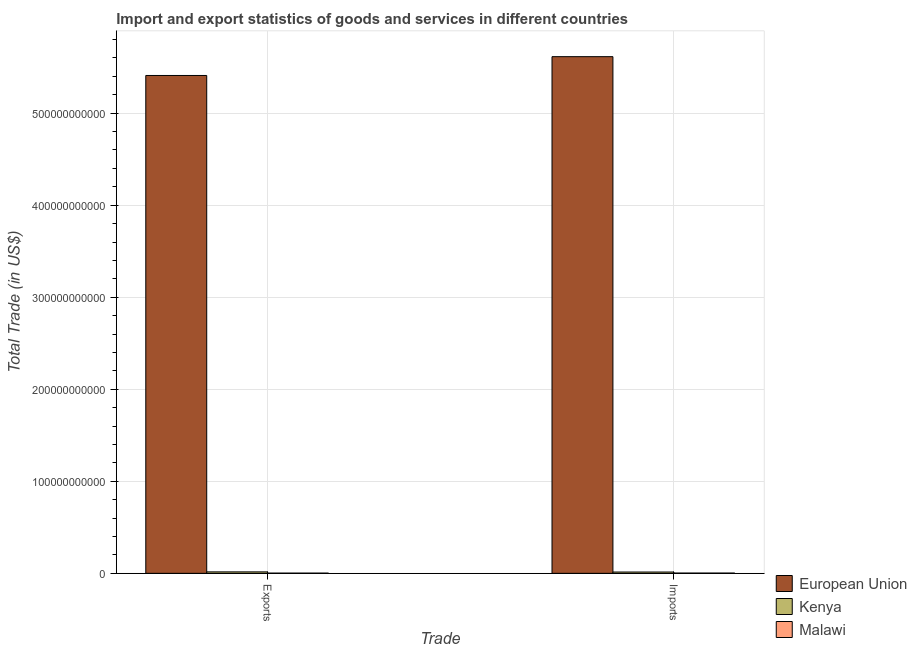How many different coloured bars are there?
Provide a succinct answer. 3. How many groups of bars are there?
Your response must be concise. 2. How many bars are there on the 1st tick from the right?
Keep it short and to the point. 3. What is the label of the 1st group of bars from the left?
Ensure brevity in your answer.  Exports. What is the imports of goods and services in Kenya?
Your response must be concise. 1.42e+09. Across all countries, what is the maximum export of goods and services?
Ensure brevity in your answer.  5.41e+11. Across all countries, what is the minimum imports of goods and services?
Offer a very short reply. 2.79e+08. In which country was the export of goods and services maximum?
Your answer should be compact. European Union. In which country was the export of goods and services minimum?
Offer a very short reply. Malawi. What is the total export of goods and services in the graph?
Ensure brevity in your answer.  5.43e+11. What is the difference between the export of goods and services in Kenya and that in European Union?
Provide a succinct answer. -5.39e+11. What is the difference between the imports of goods and services in European Union and the export of goods and services in Kenya?
Offer a very short reply. 5.60e+11. What is the average export of goods and services per country?
Your answer should be very brief. 1.81e+11. What is the difference between the imports of goods and services and export of goods and services in European Union?
Offer a very short reply. 2.05e+1. In how many countries, is the imports of goods and services greater than 480000000000 US$?
Your response must be concise. 1. What is the ratio of the export of goods and services in European Union to that in Kenya?
Give a very brief answer. 344.3. Is the export of goods and services in Kenya less than that in European Union?
Keep it short and to the point. Yes. What does the 1st bar from the right in Exports represents?
Your answer should be compact. Malawi. How many bars are there?
Your answer should be very brief. 6. How many countries are there in the graph?
Ensure brevity in your answer.  3. What is the difference between two consecutive major ticks on the Y-axis?
Offer a terse response. 1.00e+11. Are the values on the major ticks of Y-axis written in scientific E-notation?
Provide a succinct answer. No. Does the graph contain any zero values?
Provide a succinct answer. No. Where does the legend appear in the graph?
Give a very brief answer. Bottom right. What is the title of the graph?
Your answer should be compact. Import and export statistics of goods and services in different countries. What is the label or title of the X-axis?
Offer a very short reply. Trade. What is the label or title of the Y-axis?
Your answer should be very brief. Total Trade (in US$). What is the Total Trade (in US$) in European Union in Exports?
Offer a terse response. 5.41e+11. What is the Total Trade (in US$) in Kenya in Exports?
Provide a succinct answer. 1.57e+09. What is the Total Trade (in US$) of Malawi in Exports?
Provide a short and direct response. 2.42e+08. What is the Total Trade (in US$) of European Union in Imports?
Provide a short and direct response. 5.61e+11. What is the Total Trade (in US$) of Kenya in Imports?
Your answer should be compact. 1.42e+09. What is the Total Trade (in US$) in Malawi in Imports?
Provide a succinct answer. 2.79e+08. Across all Trade, what is the maximum Total Trade (in US$) in European Union?
Provide a short and direct response. 5.61e+11. Across all Trade, what is the maximum Total Trade (in US$) of Kenya?
Keep it short and to the point. 1.57e+09. Across all Trade, what is the maximum Total Trade (in US$) in Malawi?
Ensure brevity in your answer.  2.79e+08. Across all Trade, what is the minimum Total Trade (in US$) of European Union?
Your response must be concise. 5.41e+11. Across all Trade, what is the minimum Total Trade (in US$) of Kenya?
Offer a terse response. 1.42e+09. Across all Trade, what is the minimum Total Trade (in US$) of Malawi?
Offer a very short reply. 2.42e+08. What is the total Total Trade (in US$) in European Union in the graph?
Your answer should be very brief. 1.10e+12. What is the total Total Trade (in US$) of Kenya in the graph?
Provide a short and direct response. 2.99e+09. What is the total Total Trade (in US$) in Malawi in the graph?
Offer a very short reply. 5.21e+08. What is the difference between the Total Trade (in US$) of European Union in Exports and that in Imports?
Offer a very short reply. -2.05e+1. What is the difference between the Total Trade (in US$) in Kenya in Exports and that in Imports?
Keep it short and to the point. 1.51e+08. What is the difference between the Total Trade (in US$) of Malawi in Exports and that in Imports?
Your answer should be compact. -3.73e+07. What is the difference between the Total Trade (in US$) in European Union in Exports and the Total Trade (in US$) in Kenya in Imports?
Ensure brevity in your answer.  5.40e+11. What is the difference between the Total Trade (in US$) in European Union in Exports and the Total Trade (in US$) in Malawi in Imports?
Give a very brief answer. 5.41e+11. What is the difference between the Total Trade (in US$) in Kenya in Exports and the Total Trade (in US$) in Malawi in Imports?
Provide a short and direct response. 1.29e+09. What is the average Total Trade (in US$) in European Union per Trade?
Offer a terse response. 5.51e+11. What is the average Total Trade (in US$) in Kenya per Trade?
Provide a short and direct response. 1.50e+09. What is the average Total Trade (in US$) in Malawi per Trade?
Provide a short and direct response. 2.61e+08. What is the difference between the Total Trade (in US$) in European Union and Total Trade (in US$) in Kenya in Exports?
Make the answer very short. 5.39e+11. What is the difference between the Total Trade (in US$) in European Union and Total Trade (in US$) in Malawi in Exports?
Your answer should be compact. 5.41e+11. What is the difference between the Total Trade (in US$) of Kenya and Total Trade (in US$) of Malawi in Exports?
Provide a short and direct response. 1.33e+09. What is the difference between the Total Trade (in US$) of European Union and Total Trade (in US$) of Kenya in Imports?
Your answer should be very brief. 5.60e+11. What is the difference between the Total Trade (in US$) of European Union and Total Trade (in US$) of Malawi in Imports?
Your answer should be very brief. 5.61e+11. What is the difference between the Total Trade (in US$) in Kenya and Total Trade (in US$) in Malawi in Imports?
Ensure brevity in your answer.  1.14e+09. What is the ratio of the Total Trade (in US$) of European Union in Exports to that in Imports?
Your response must be concise. 0.96. What is the ratio of the Total Trade (in US$) in Kenya in Exports to that in Imports?
Keep it short and to the point. 1.11. What is the ratio of the Total Trade (in US$) of Malawi in Exports to that in Imports?
Your answer should be compact. 0.87. What is the difference between the highest and the second highest Total Trade (in US$) of European Union?
Offer a terse response. 2.05e+1. What is the difference between the highest and the second highest Total Trade (in US$) of Kenya?
Your response must be concise. 1.51e+08. What is the difference between the highest and the second highest Total Trade (in US$) of Malawi?
Provide a short and direct response. 3.73e+07. What is the difference between the highest and the lowest Total Trade (in US$) in European Union?
Your answer should be very brief. 2.05e+1. What is the difference between the highest and the lowest Total Trade (in US$) in Kenya?
Provide a short and direct response. 1.51e+08. What is the difference between the highest and the lowest Total Trade (in US$) in Malawi?
Offer a very short reply. 3.73e+07. 